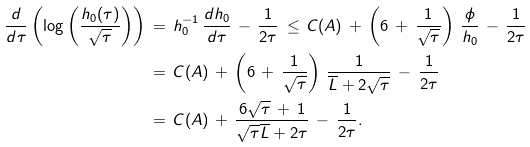Convert formula to latex. <formula><loc_0><loc_0><loc_500><loc_500>\frac { d } { d \tau } \left ( \log \left ( \frac { h _ { 0 } ( \tau ) } { \sqrt { \tau } } \right ) \right ) \, & = \, h _ { 0 } ^ { - 1 } \, \frac { d h _ { 0 } } { d \tau } \, - \, \frac { 1 } { 2 \tau } \, \leq \, C ( A ) \, + \, \left ( 6 \, + \, \frac { 1 } { \sqrt { \tau } } \right ) \, \frac { \phi } { h _ { 0 } } \, - \, \frac { 1 } { 2 \tau } \\ & = \, C ( A ) \, + \, \left ( 6 \, + \, \frac { 1 } { \sqrt { \tau } } \right ) \, \frac { 1 } { \overline { L } + 2 \sqrt { \tau } } \, - \, \frac { 1 } { 2 \tau } \\ & = \, C ( A ) \, + \, \frac { 6 \sqrt { \tau } \, + \, 1 } { \sqrt { \tau } \overline { L } + 2 { \tau } } \, - \, \frac { 1 } { 2 \tau } .</formula> 